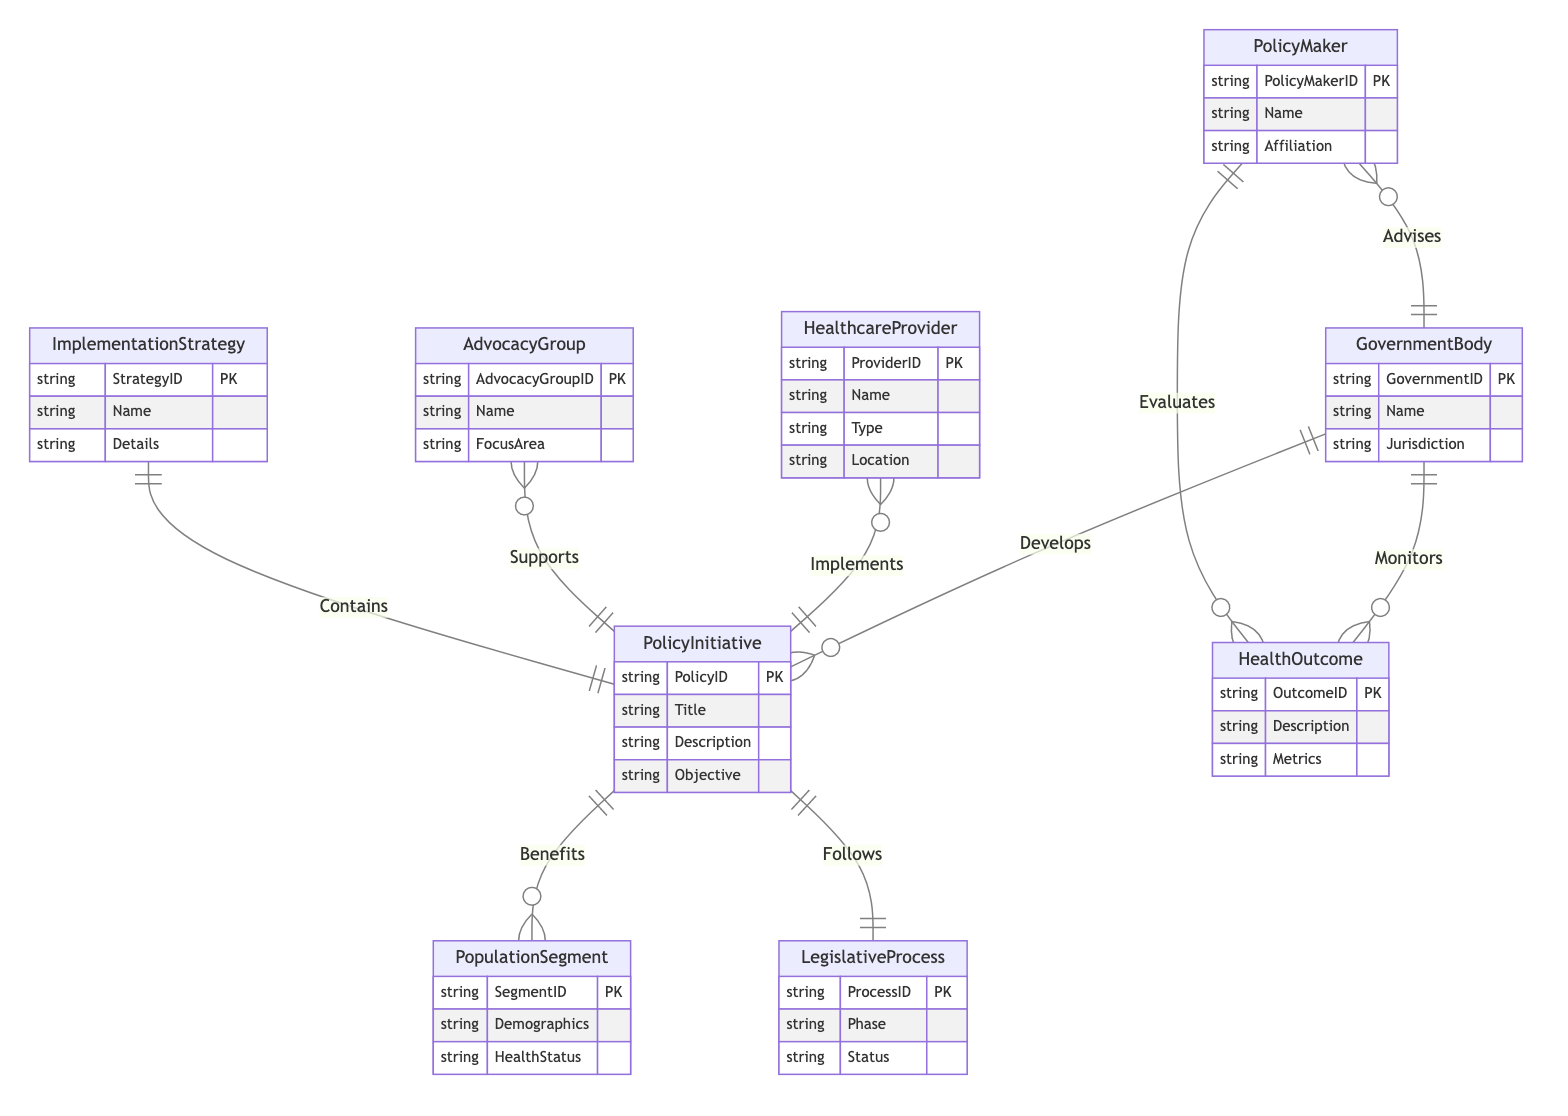What are the entities involved in the diagram? The diagram includes nine entities: GovernmentBody, PolicyMaker, HealthcareProvider, AdvocacyGroup, PopulationSegment, PolicyInitiative, LegislativeProcess, ImplementationStrategy, and HealthOutcome.
Answer: GovernmentBody, PolicyMaker, HealthcareProvider, AdvocacyGroup, PopulationSegment, PolicyInitiative, LegislativeProcess, ImplementationStrategy, HealthOutcome How many relationships are defined in the diagram? The diagram defines eight relationships: Develops, Advises, Implements, Supports, Benefits, Monitors, Evaluates, Follows, and Contains.
Answer: Eight What is the relationship between GovernmentBody and PolicyInitiative? The diagram shows that GovernmentBody develops PolicyInitiative, indicating a direct action taken by the GovernmentBody regarding policy creation.
Answer: Develops Which entity advises the GovernmentBody? The PolicyMaker advises the GovernmentBody, as shown by the relationship labeled "Advises" connecting these two entities.
Answer: PolicyMaker Which entity implements the PolicyInitiative? HealthcareProvider implements the PolicyInitiative, as indicated by the relationship labeled "Implements" connecting them in the diagram.
Answer: HealthcareProvider What is the purpose of the relationship labeled "Monitors"? The "Monitors" relationship indicates that the GovernmentBody is responsible for monitoring HealthOutcomes, ensuring ongoing evaluation of health initiatives.
Answer: HealthOutcome How does PolicyInitiative benefit the PopulationSegment? The PolicyInitiative benefits the PopulationSegment, meaning that policy initiatives are designed to positively impact specific demographic groups, as shown in the diagram.
Answer: Benefits Which entity is responsible for following the LegislativeProcess? The PolicyInitiative follows the LegislativeProcess, indicating the need for policy initiatives to proceed through legislative procedures to be enacted.
Answer: LegislativeProcess What type of information does the ImplementationStrategy contain? The ImplementationStrategy contains details acting as a framework or plan supporting the execution of a specific PolicyInitiative, according to the relationship labeled "Contains".
Answer: PolicyInitiative 